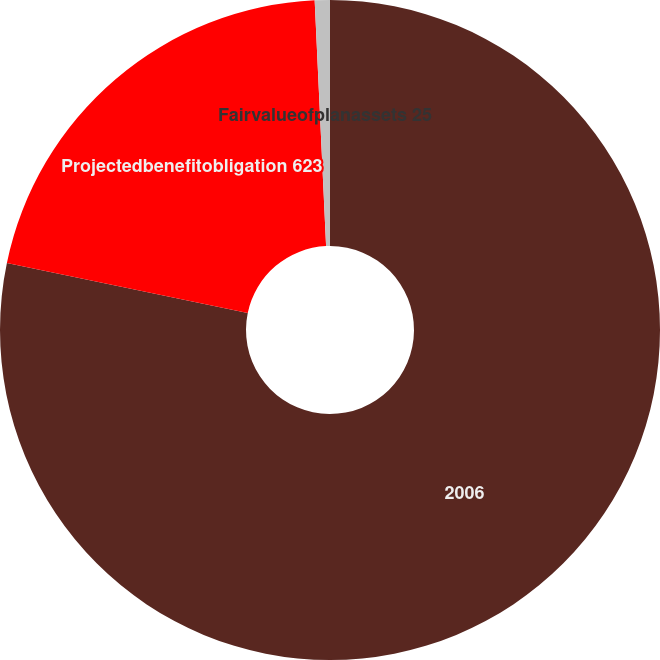<chart> <loc_0><loc_0><loc_500><loc_500><pie_chart><fcel>2006<fcel>Projectedbenefitobligation 623<fcel>Fairvalueofplanassets 25<nl><fcel>78.26%<fcel>21.0%<fcel>0.74%<nl></chart> 